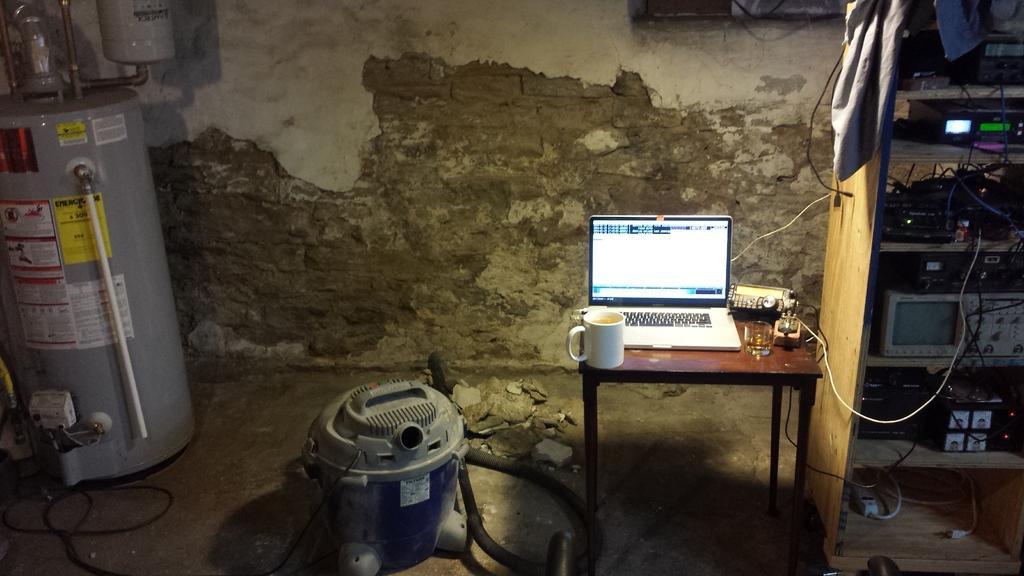Could you give a brief overview of what you see in this image? In this Image I see a laptop, a cup, a glass and few equipment on this table and I see many equipment in this rack. In the background I see the wall. 